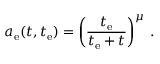<formula> <loc_0><loc_0><loc_500><loc_500>a _ { e } ( t , t _ { e } ) = \left ( \frac { t _ { e } } { t _ { e } + t } \right ) ^ { \mu } \, .</formula> 